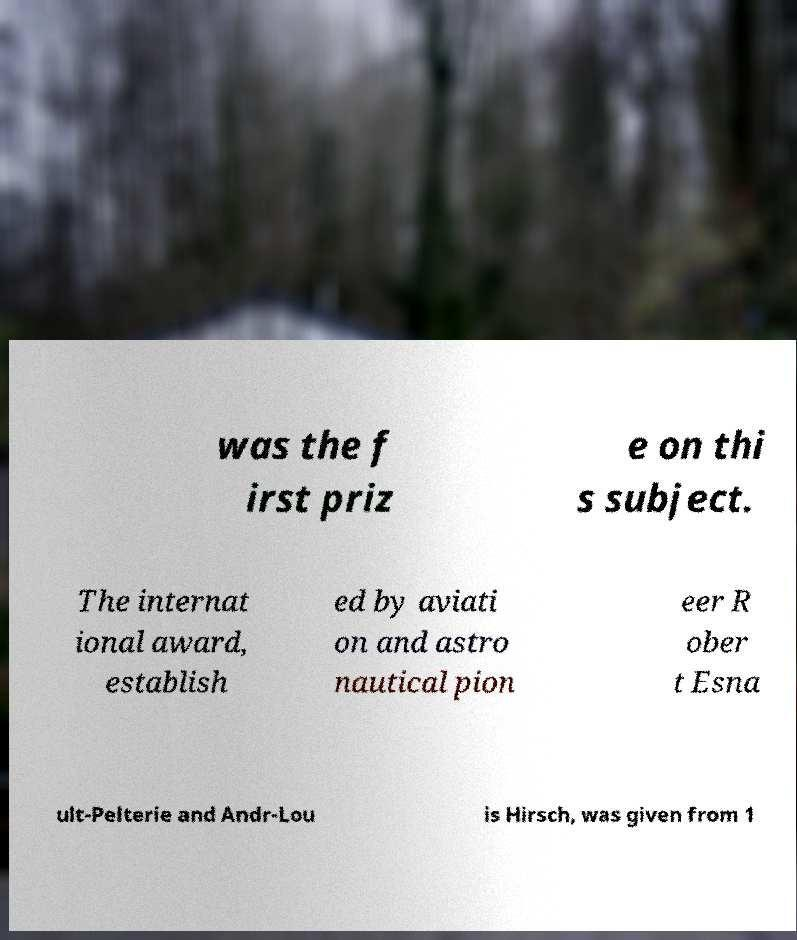I need the written content from this picture converted into text. Can you do that? was the f irst priz e on thi s subject. The internat ional award, establish ed by aviati on and astro nautical pion eer R ober t Esna ult-Pelterie and Andr-Lou is Hirsch, was given from 1 